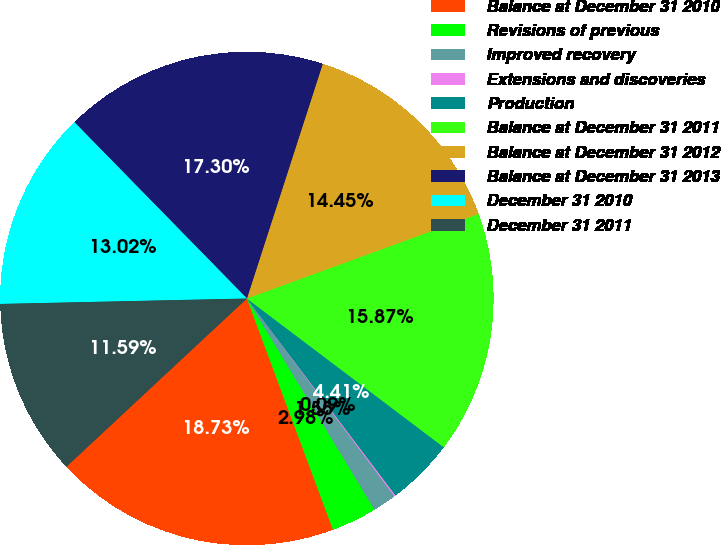<chart> <loc_0><loc_0><loc_500><loc_500><pie_chart><fcel>Balance at December 31 2010<fcel>Revisions of previous<fcel>Improved recovery<fcel>Extensions and discoveries<fcel>Production<fcel>Balance at December 31 2011<fcel>Balance at December 31 2012<fcel>Balance at December 31 2013<fcel>December 31 2010<fcel>December 31 2011<nl><fcel>18.73%<fcel>2.98%<fcel>1.55%<fcel>0.09%<fcel>4.41%<fcel>15.87%<fcel>14.45%<fcel>17.3%<fcel>13.02%<fcel>11.59%<nl></chart> 